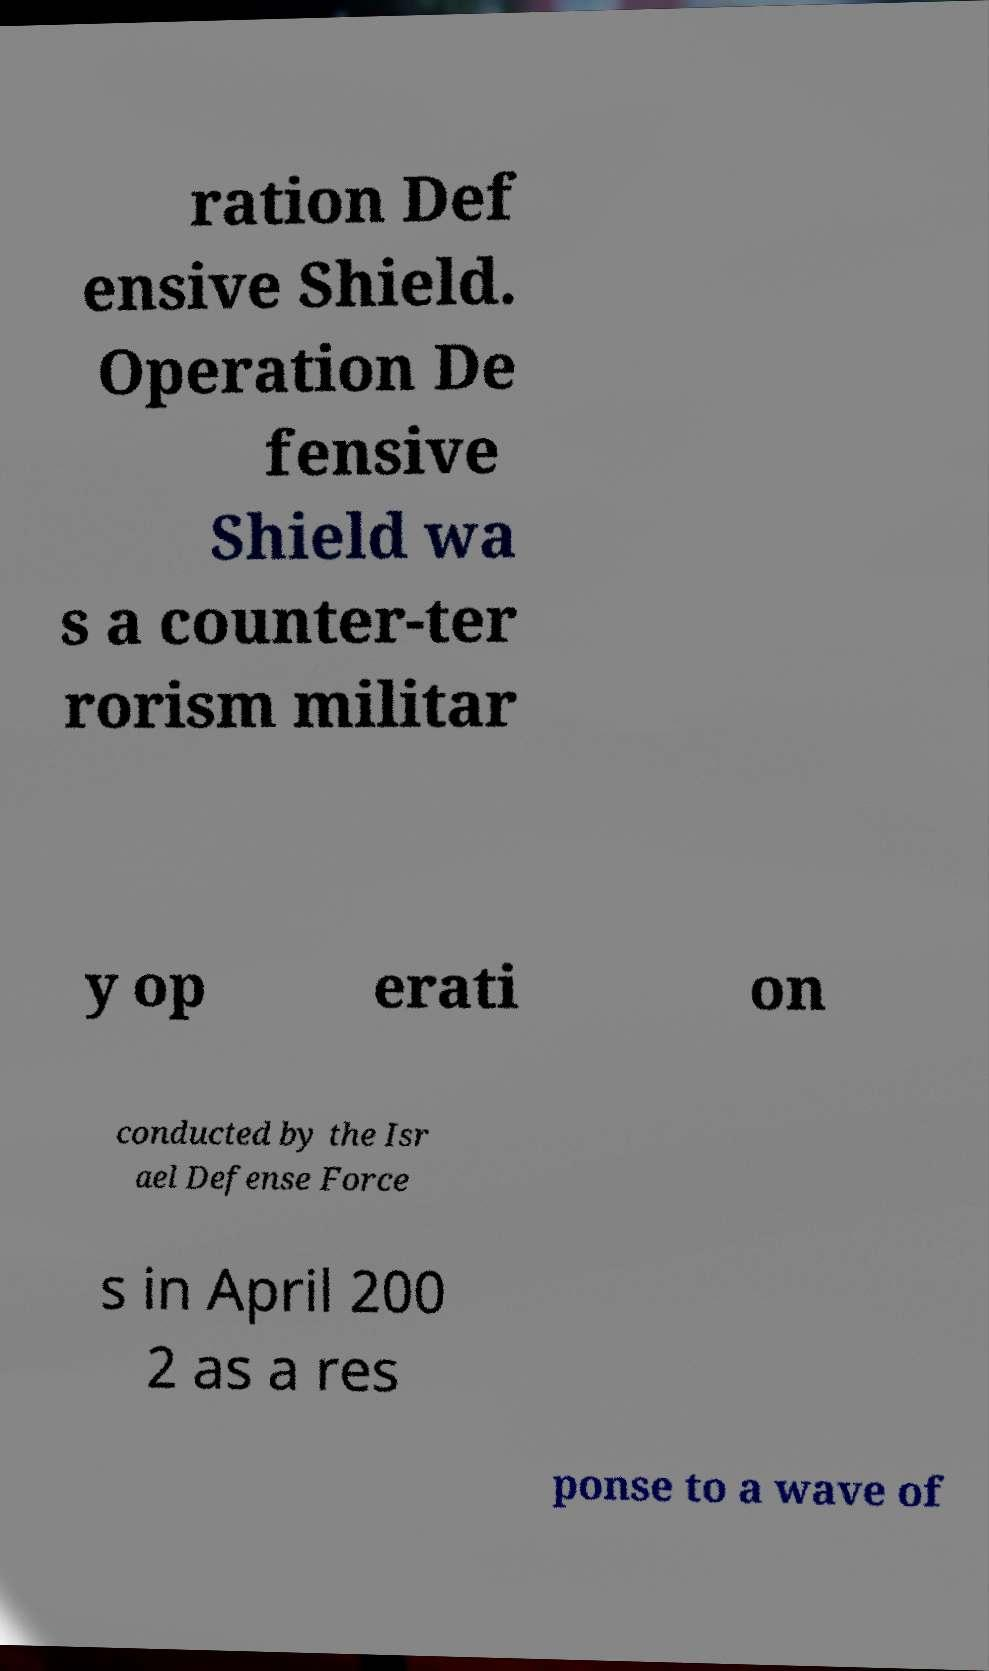Can you accurately transcribe the text from the provided image for me? ration Def ensive Shield. Operation De fensive Shield wa s a counter-ter rorism militar y op erati on conducted by the Isr ael Defense Force s in April 200 2 as a res ponse to a wave of 